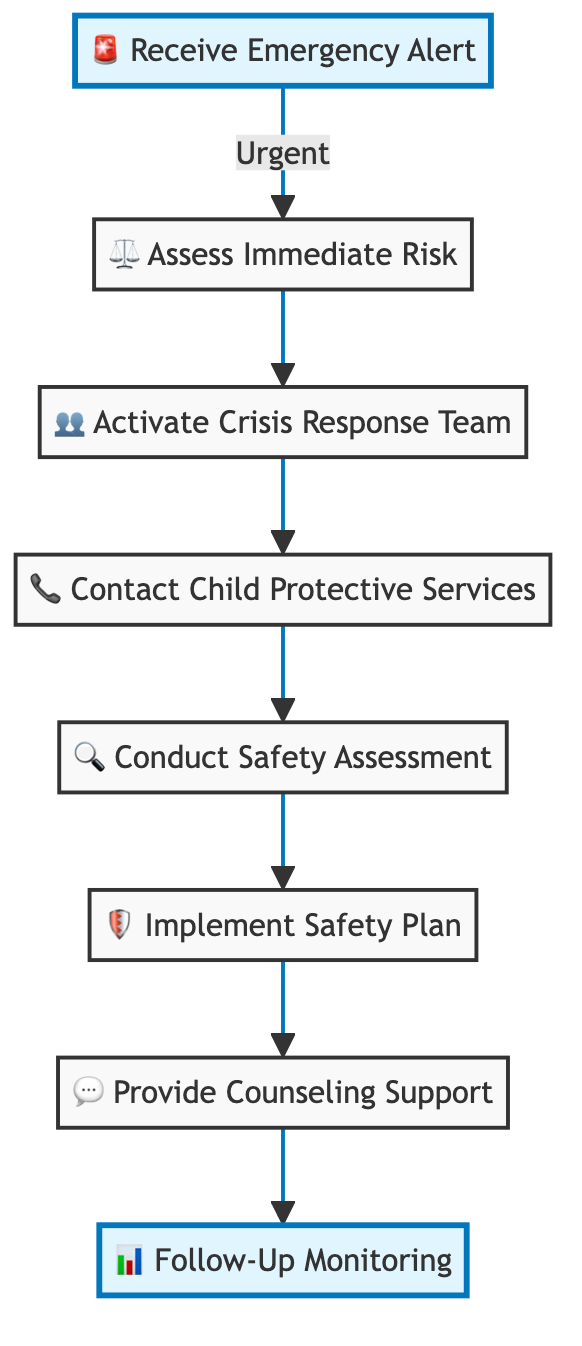What is the first step in the emergency response workflow? The first step, as indicated in the diagram, is "Receive Emergency Alert," which initiates the workflow.
Answer: Receive Emergency Alert How many steps are there in the workflow? The diagram contains a total of eight steps, as listed from the initial to the final actions in the workflow.
Answer: 8 What action follows "Assess Immediate Risk"? According to the flowchart, the action that follows "Assess Immediate Risk" is "Activate Crisis Response Team."
Answer: Activate Crisis Response Team Which step involves contacting authorities? The step that involves contacting authorities is "Contact Child Protective Services," as seen in the sequence of the workflow.
Answer: Contact Child Protective Services What is the last step in the workflow? The last step in the workflow, as indicated in the diagram, is "Follow-Up Monitoring," which is the final action taken after providing support.
Answer: Follow-Up Monitoring Which actions are involved in ensuring the child's safety? The actions involved in ensuring the child's safety include "Conduct Safety Assessment," "Implement Safety Plan," and "Provide Counseling Support," collectively forming the core safety measures.
Answer: Conduct Safety Assessment, Implement Safety Plan, Provide Counseling Support What is the relationship between “Activate Crisis Response Team” and “Contact Child Protective Services”? The relationship is sequential: after "Activate Crisis Response Team," the next step is to "Contact Child Protective Services," demonstrating a direct flow from one action to the next in the emergency response process.
Answer: Sequential relationship Which steps highlight the focus on child support? The steps highlighting the focus on child support are "Provide Counseling Support" and "Follow-Up Monitoring," as they specifically deal with the child's emotional and ongoing well-being post-intervention.
Answer: Provide Counseling Support, Follow-Up Monitoring 